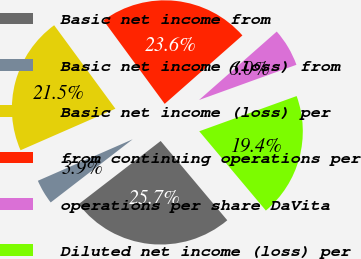Convert chart. <chart><loc_0><loc_0><loc_500><loc_500><pie_chart><fcel>Basic net income from<fcel>Basic net income (loss) from<fcel>Basic net income (loss) per<fcel>from continuing operations per<fcel>operations per share DaVita<fcel>Diluted net income (loss) per<nl><fcel>25.67%<fcel>3.88%<fcel>21.49%<fcel>23.58%<fcel>5.97%<fcel>19.4%<nl></chart> 